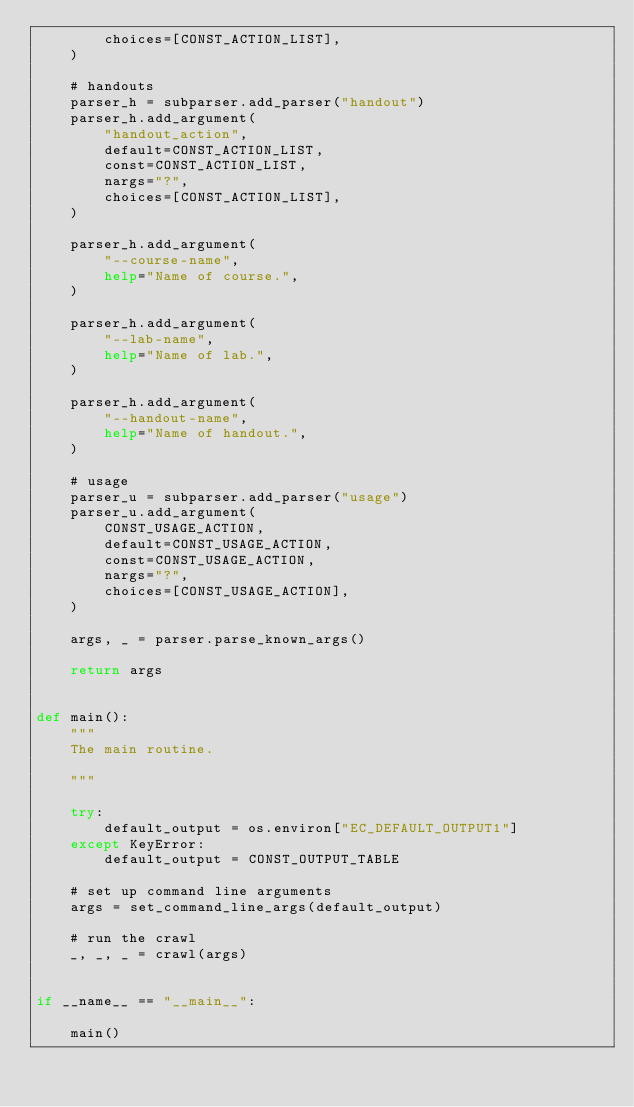<code> <loc_0><loc_0><loc_500><loc_500><_Python_>        choices=[CONST_ACTION_LIST],
    )

    # handouts
    parser_h = subparser.add_parser("handout")
    parser_h.add_argument(
        "handout_action",
        default=CONST_ACTION_LIST,
        const=CONST_ACTION_LIST,
        nargs="?",
        choices=[CONST_ACTION_LIST],
    )

    parser_h.add_argument(
        "--course-name",
        help="Name of course.",
    )

    parser_h.add_argument(
        "--lab-name",
        help="Name of lab.",
    )

    parser_h.add_argument(
        "--handout-name",
        help="Name of handout.",
    )

    # usage
    parser_u = subparser.add_parser("usage")
    parser_u.add_argument(
        CONST_USAGE_ACTION,
        default=CONST_USAGE_ACTION,
        const=CONST_USAGE_ACTION,
        nargs="?",
        choices=[CONST_USAGE_ACTION],
    )

    args, _ = parser.parse_known_args()

    return args


def main():
    """
    The main routine.

    """

    try:
        default_output = os.environ["EC_DEFAULT_OUTPUT1"]
    except KeyError:
        default_output = CONST_OUTPUT_TABLE

    # set up command line arguments
    args = set_command_line_args(default_output)

    # run the crawl
    _, _, _ = crawl(args)


if __name__ == "__main__":

    main()
</code> 